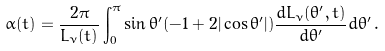Convert formula to latex. <formula><loc_0><loc_0><loc_500><loc_500>\alpha ( t ) = \frac { 2 \pi } { L _ { \nu } ( t ) } \int _ { 0 } ^ { \pi } \sin \theta ^ { \prime } ( - 1 + 2 | \cos \theta ^ { \prime } | ) \frac { d L _ { \nu } ( \theta ^ { \prime } , t ) } { d \theta ^ { \prime } } d \theta ^ { \prime } \, .</formula> 